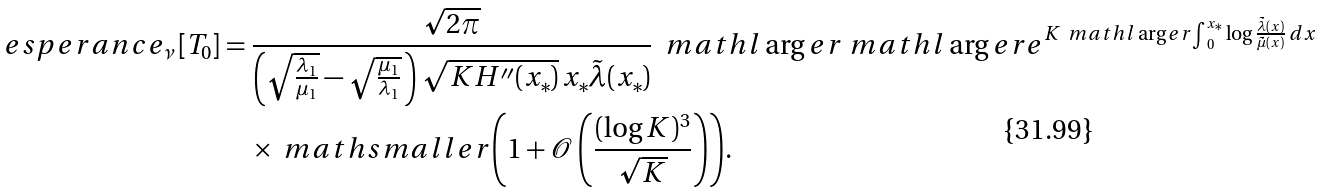Convert formula to latex. <formula><loc_0><loc_0><loc_500><loc_500>\ e s p e r a n c e _ { \nu } \left [ T _ { 0 } \right ] & = \frac { \sqrt { 2 \pi } } { \left ( \sqrt { \frac { \lambda _ { 1 } } { \mu _ { 1 } } } - \sqrt { \frac { \mu _ { 1 } } { \lambda _ { 1 } } } \, \right ) \sqrt { K H ^ { \prime \prime } ( x _ { * } ) } \, x _ { * } \tilde { \lambda } ( x _ { * } ) } \ \ m a t h l \arg e r { \ m a t h l \arg e r { e } } ^ { K \ m a t h l \arg e r { \int } _ { 0 } ^ { x _ { * } } \log \frac { \tilde { \lambda } ( x ) } { \tilde { \mu } ( x ) } \, d x } \\ & \quad \times \ m a t h s m a l l e r { \left ( 1 + \mathcal { O } \left ( \frac { ( \log K ) ^ { 3 } } { \sqrt { K } } \right ) \right ) } .</formula> 